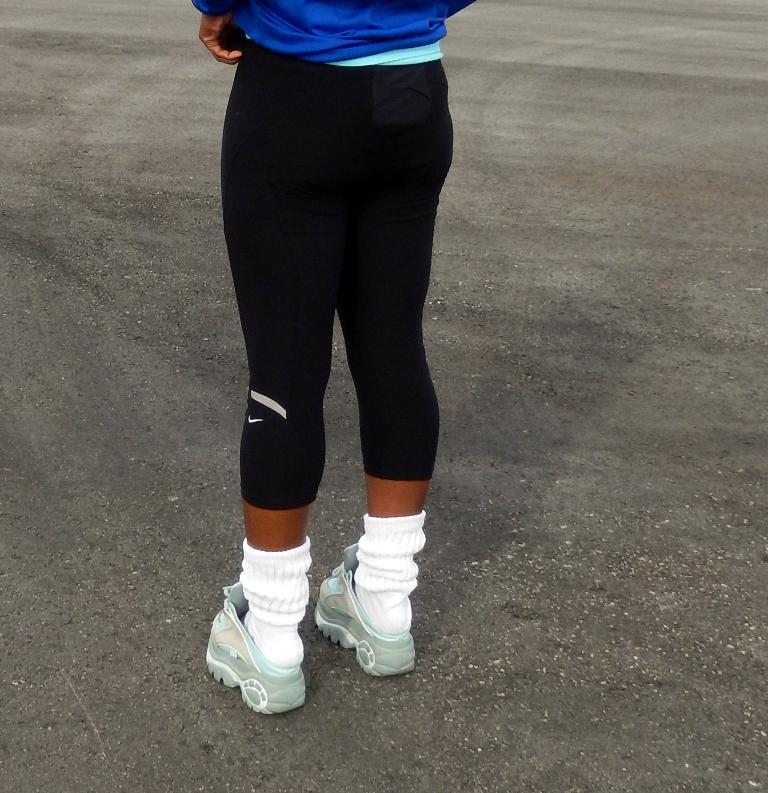What is present in the image? There is a person in the image. What is the person doing in the image? The person is standing on the ground. What type of potato can be seen in the image? There is no potato present in the image. What sound is being made by the person in the image? The image does not provide any information about the person making a sound. 